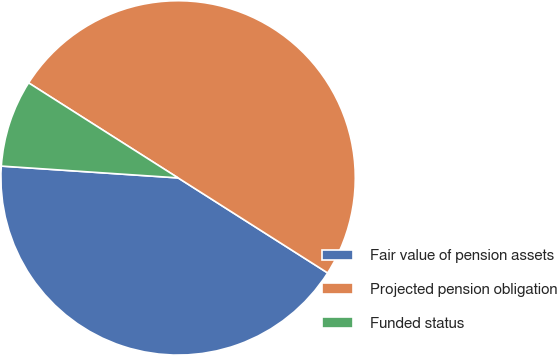Convert chart to OTSL. <chart><loc_0><loc_0><loc_500><loc_500><pie_chart><fcel>Fair value of pension assets<fcel>Projected pension obligation<fcel>Funded status<nl><fcel>42.05%<fcel>50.0%<fcel>7.95%<nl></chart> 